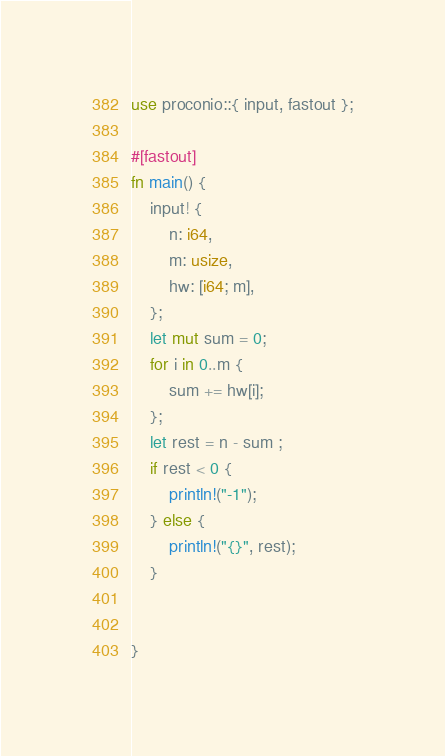<code> <loc_0><loc_0><loc_500><loc_500><_Rust_>
use proconio::{ input, fastout };

#[fastout]
fn main() {
    input! {
        n: i64,
        m: usize,
        hw: [i64; m],
    };
    let mut sum = 0;
    for i in 0..m {
        sum += hw[i];
    };
    let rest = n - sum ;
    if rest < 0 {
        println!("-1");
    } else {
        println!("{}", rest);
    }


}
</code> 